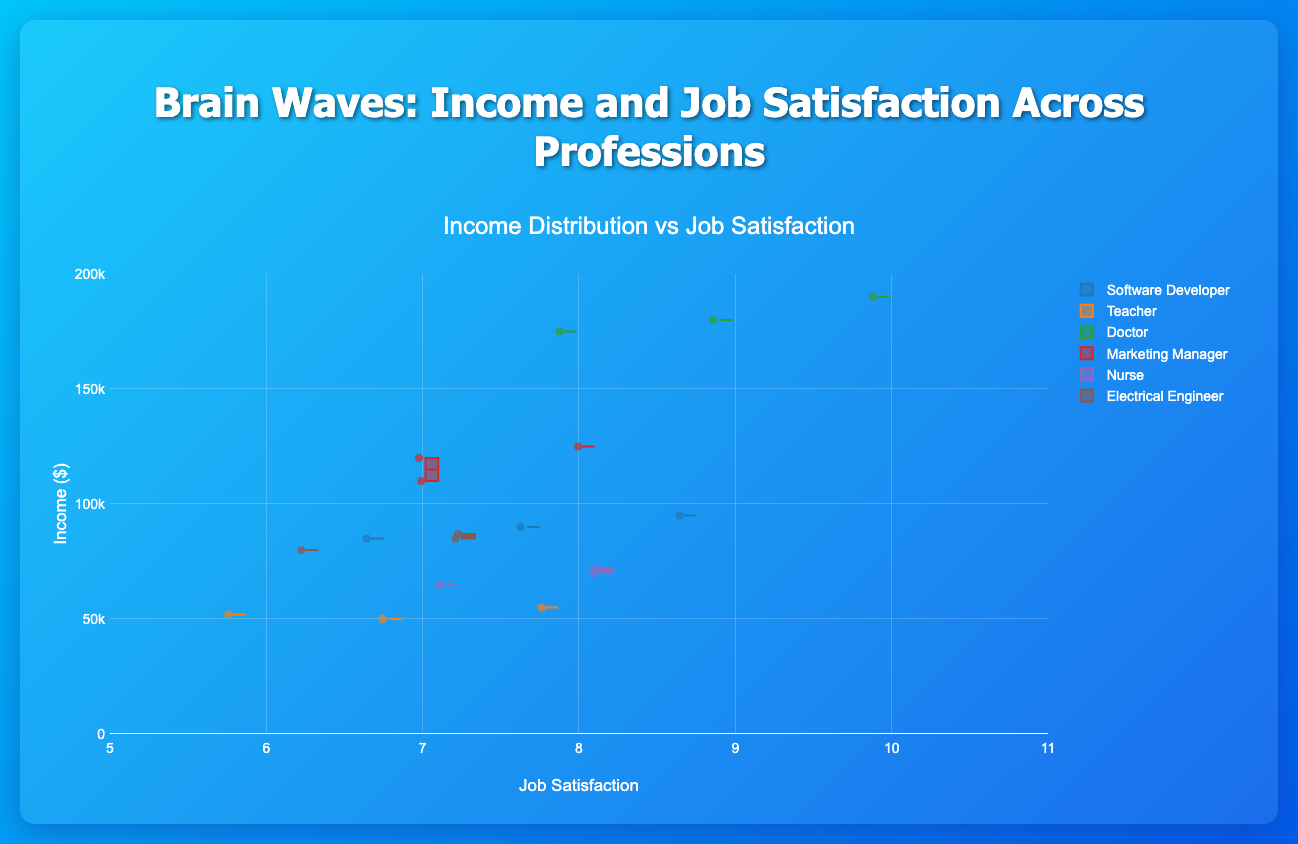What are the professions included in the figure? Observing the x-axis labels, which represent different professions, we can list the professions present in the figure.
Answer: Software Developer, Teacher, Doctor, Marketing Manager, Nurse, Electrical Engineer What is the general relationship between income and job satisfaction? By looking at the distribution and trends of the data points within each profession, we notice that generally, professions with higher income tend to have higher job satisfaction ratings.
Answer: Higher income tends to correlate with higher job satisfaction What profession has the widest range of income? By comparing the range between the lowest and highest income values in each profession's box plot, we can determine which has the widest range.
Answer: Doctor Which profession has the highest median income? The median income corresponds to the middle line within each box of the box plot. By observing these lines for each profession, we identify the one with the highest position on the y-axis.
Answer: Doctor Which profession appears to have the highest job satisfaction despite a lower income range? By comparing the income ranges and job satisfaction ratings across professions, we can identify one that has lower income but relatively high job satisfaction.
Answer: Nursing What is the income and job satisfaction of the lowest paid Electrical Engineer? Observing the specific points within the Electrical Engineer box plot, locate the lowest data point and read off its income and job satisfaction values.
Answer: $80,000 and 6 For which profession do all the data points cluster tightly around one value, suggesting similar experiences among professionals? Check where the box plot has relatively narrow whiskers and many points closely clustered.
Answer: Electrical Engineer Which profession has the most outliers in their income distribution? Outliers in a box plot are typically individual points that are distant from the main box and whiskers. Compare the number of such points for each profession.
Answer: Software Developer What is the median job satisfaction for Teachers? Identify the median line within the Teacher box, then move down to the x-axis to read the job satisfaction value.
Answer: 7 Which profession shows the least variability in job satisfaction? The box plot with the narrowest width in terms of x-axis (job satisfaction) variation represents the profession with the least variability.
Answer: Nurse Which profession's income distribution has its highest interquartile range? The interquartile range (IQR) is shown by the height of the box. By comparing the heights of all boxes, we can find the profession with the highest IQR in income.
Answer: Doctor Which profession shows a positive correlation between income and job satisfaction with wider variance in job satisfaction? By correlating the box plots on both y (income) and x (job satisfaction) axes, we can find a group where increasing income also increases job satisfaction with larger variance in the measurements.
Answer: Marketing Manager 